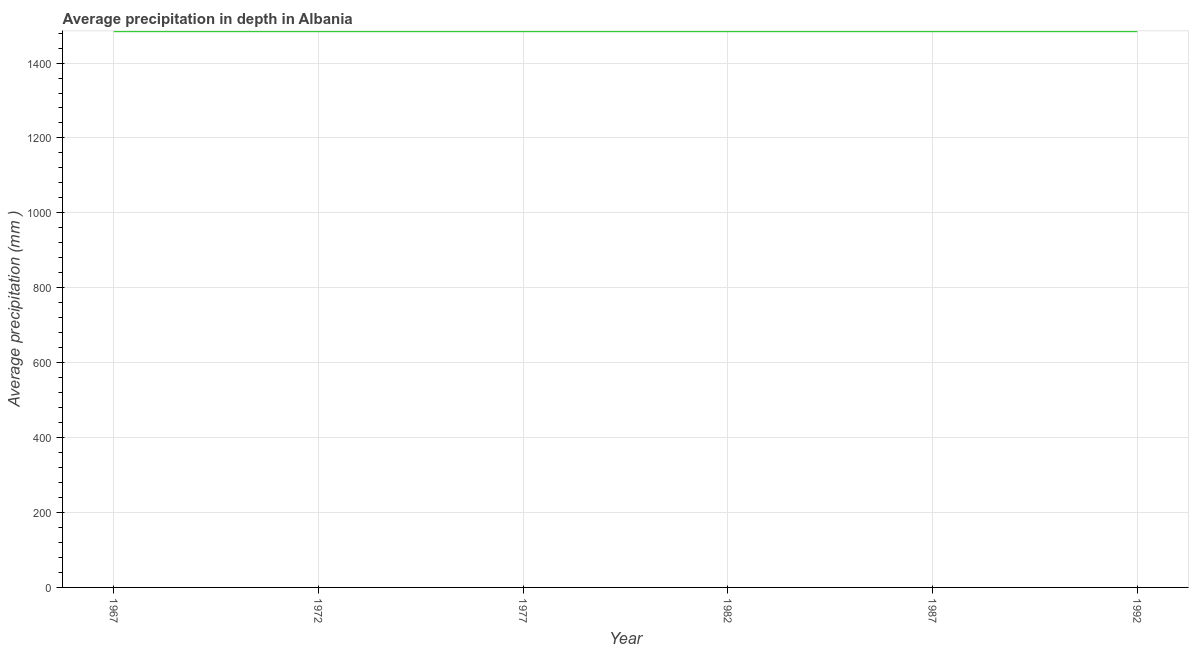What is the average precipitation in depth in 1977?
Make the answer very short. 1485. Across all years, what is the maximum average precipitation in depth?
Offer a terse response. 1485. Across all years, what is the minimum average precipitation in depth?
Ensure brevity in your answer.  1485. In which year was the average precipitation in depth maximum?
Give a very brief answer. 1967. In which year was the average precipitation in depth minimum?
Your response must be concise. 1967. What is the sum of the average precipitation in depth?
Ensure brevity in your answer.  8910. What is the average average precipitation in depth per year?
Provide a succinct answer. 1485. What is the median average precipitation in depth?
Keep it short and to the point. 1485. In how many years, is the average precipitation in depth greater than 640 mm?
Your response must be concise. 6. What is the ratio of the average precipitation in depth in 1982 to that in 1992?
Your response must be concise. 1. Is the sum of the average precipitation in depth in 1977 and 1982 greater than the maximum average precipitation in depth across all years?
Keep it short and to the point. Yes. What is the difference between the highest and the lowest average precipitation in depth?
Offer a very short reply. 0. In how many years, is the average precipitation in depth greater than the average average precipitation in depth taken over all years?
Give a very brief answer. 0. How many lines are there?
Provide a short and direct response. 1. How many years are there in the graph?
Your answer should be compact. 6. Does the graph contain grids?
Your response must be concise. Yes. What is the title of the graph?
Offer a very short reply. Average precipitation in depth in Albania. What is the label or title of the X-axis?
Your answer should be compact. Year. What is the label or title of the Y-axis?
Offer a terse response. Average precipitation (mm ). What is the Average precipitation (mm ) in 1967?
Keep it short and to the point. 1485. What is the Average precipitation (mm ) of 1972?
Provide a short and direct response. 1485. What is the Average precipitation (mm ) in 1977?
Offer a very short reply. 1485. What is the Average precipitation (mm ) of 1982?
Give a very brief answer. 1485. What is the Average precipitation (mm ) of 1987?
Ensure brevity in your answer.  1485. What is the Average precipitation (mm ) in 1992?
Provide a short and direct response. 1485. What is the difference between the Average precipitation (mm ) in 1967 and 1977?
Provide a succinct answer. 0. What is the difference between the Average precipitation (mm ) in 1972 and 1992?
Make the answer very short. 0. What is the difference between the Average precipitation (mm ) in 1977 and 1982?
Give a very brief answer. 0. What is the difference between the Average precipitation (mm ) in 1982 and 1987?
Offer a very short reply. 0. What is the difference between the Average precipitation (mm ) in 1987 and 1992?
Your answer should be compact. 0. What is the ratio of the Average precipitation (mm ) in 1967 to that in 1977?
Make the answer very short. 1. What is the ratio of the Average precipitation (mm ) in 1967 to that in 1987?
Keep it short and to the point. 1. What is the ratio of the Average precipitation (mm ) in 1972 to that in 1987?
Your answer should be compact. 1. What is the ratio of the Average precipitation (mm ) in 1972 to that in 1992?
Make the answer very short. 1. What is the ratio of the Average precipitation (mm ) in 1977 to that in 1992?
Provide a short and direct response. 1. What is the ratio of the Average precipitation (mm ) in 1982 to that in 1992?
Your response must be concise. 1. 